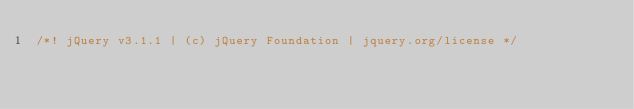<code> <loc_0><loc_0><loc_500><loc_500><_JavaScript_>/*! jQuery v3.1.1 | (c) jQuery Foundation | jquery.org/license */</code> 